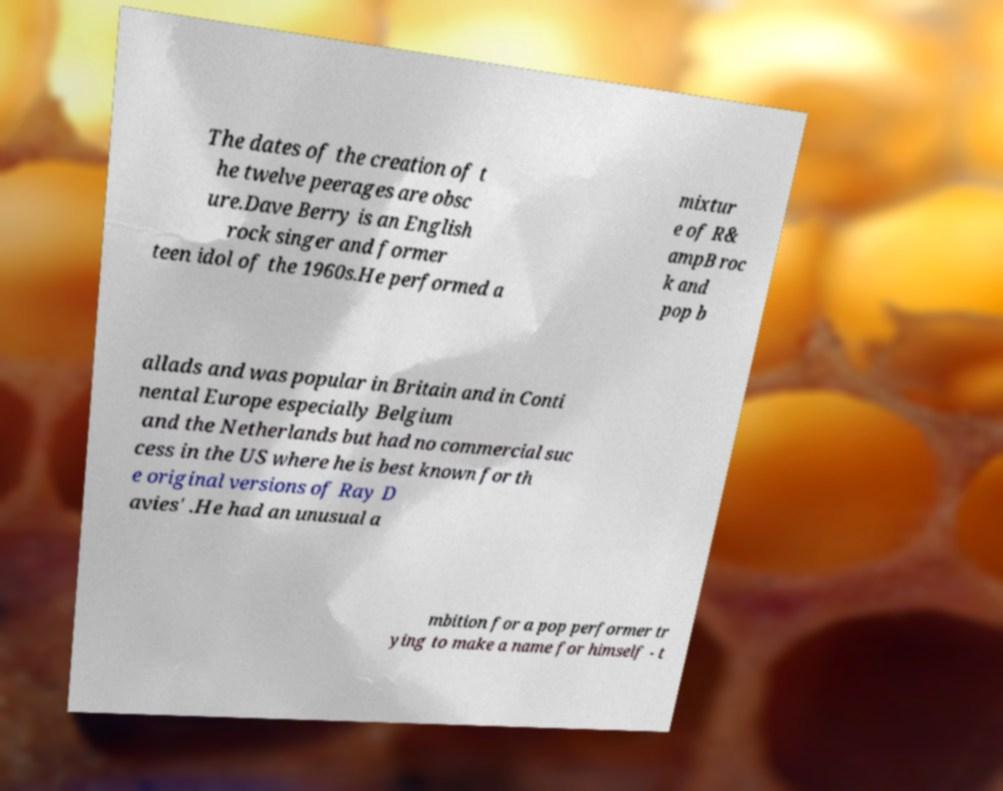Could you extract and type out the text from this image? The dates of the creation of t he twelve peerages are obsc ure.Dave Berry is an English rock singer and former teen idol of the 1960s.He performed a mixtur e of R& ampB roc k and pop b allads and was popular in Britain and in Conti nental Europe especially Belgium and the Netherlands but had no commercial suc cess in the US where he is best known for th e original versions of Ray D avies' .He had an unusual a mbition for a pop performer tr ying to make a name for himself - t 